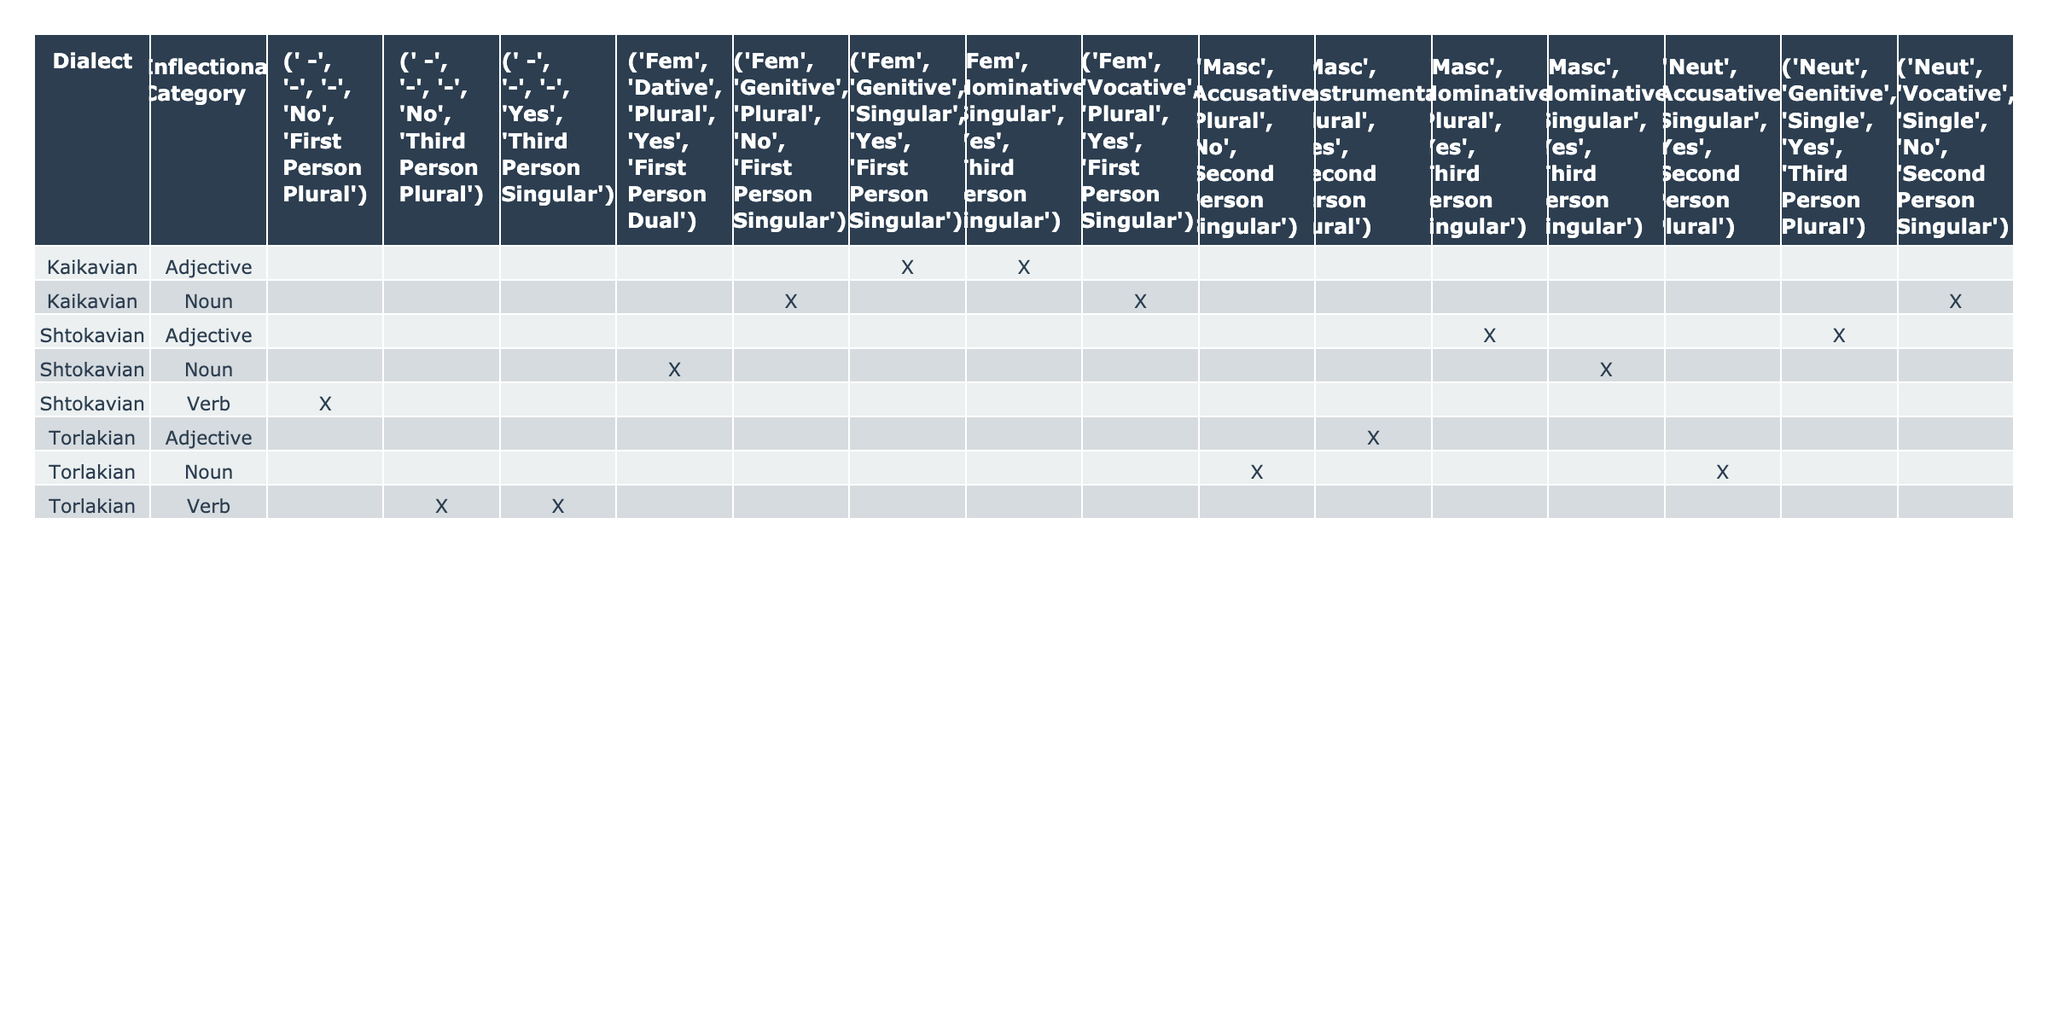What is the dominant gender for nouns in the Shtokavian dialect? In the Shtokavian dialect, the table shows that there are masculine nouns listed in the nominative singular and accusative plural, and also feminine nouns present in the dative plural. However, the masculine nouns appear more frequently. Thus, masculine is considered the dominant gender in Shtokavian nouns.
Answer: Masculine Which dialect has adjectives that agree in the nominative singular? The table indicates that both Kaikavian and Shtokavian dialects have adjectives agreeing in the nominative singular. For Kaikavian, it lists feminine adjectives and for Shtokavian, masculine adjectives are present.
Answer: Kaikavian and Shtokavian How many total noun genders are listed for the Torlakian dialect? In the Torlakian dialect, the table lists three nouns, one of each gender: masculine, feminine, and neuter. Thus, there are three different noun genders represented.
Answer: Three Is there any instance of a neuter noun in the Kaikavian dialect? The table shows that Kaikavian has a neuter noun in the vocative case, but it is listed as having singular number which has been shown incorrectly as 'Single' instead of 'Singular'. This implies that neuter nouns do exist in this dialect.
Answer: Yes Which dialect shows the highest number of adjective agreements in the plural? Upon reviewing the table, Shtokavian and Torlakian both show instances where there are adjectives with agreement in the plural. However, Shtokavian has two such instances compared to one in Torlakian. Thus, Shtokavian shows the highest number of adjective agreements in the plural.
Answer: Shtokavian Is it true that all verbs in Torlakian are conjugated in the third person? The table indicates that the only verb listed in Torlakian (which is one) does indeed conjugate in the third person. However, there are additional entries that show the absence of a verb inflection in other inflectional categories. Therefore, it is true for the provided data.
Answer: Yes How many different cases are represented for adjectives in the Shtokavian dialect? From the Shtokavian data in the table, adjectives appear in nominative and instrumental cases. This gives a total of two cases represented for adjectives in this dialect.
Answer: Two Which inflectional category has the least representation across all dialects in this table? By examining the table, we see that verbs have fewer instances compared to nouns and adjectives across all dialects, which are present multiple times. Thus, the inflectional category with the least representation is verbs.
Answer: Verb Does the Kaikavian dialect show any instances of adjectives that agree with nouns in the dative case? The table indicates that Kaikavian does not have any entries showing adjectives that agree with nouns in the dative case. Therefore, there are no such instances.
Answer: No How many genders are present for nouns in the Shtokavian dialect? The Shtokavian dialect shows masculine and feminine nouns, plus a neuter entry is indirectly implied since adjectives in neuter forms are shown. Thus, the conclusion here is that Shtokavian has three gender representations for nouns.
Answer: Three Are there any dialects where adjectives do not agree with nouns? By reviewing the table, it is clear that the Torlakian dialect has instances where it lists verb conjugations without adjective agreements or connections. This indicates that adjectives do not always align with nouns in this dialect.
Answer: Yes 